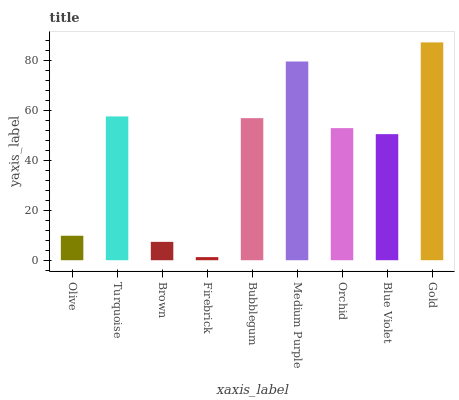Is Firebrick the minimum?
Answer yes or no. Yes. Is Gold the maximum?
Answer yes or no. Yes. Is Turquoise the minimum?
Answer yes or no. No. Is Turquoise the maximum?
Answer yes or no. No. Is Turquoise greater than Olive?
Answer yes or no. Yes. Is Olive less than Turquoise?
Answer yes or no. Yes. Is Olive greater than Turquoise?
Answer yes or no. No. Is Turquoise less than Olive?
Answer yes or no. No. Is Orchid the high median?
Answer yes or no. Yes. Is Orchid the low median?
Answer yes or no. Yes. Is Bubblegum the high median?
Answer yes or no. No. Is Brown the low median?
Answer yes or no. No. 